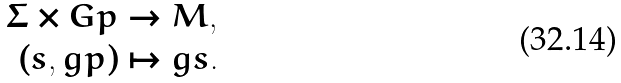<formula> <loc_0><loc_0><loc_500><loc_500>\Sigma \times G p & \to M , \\ ( s , g p ) & \mapsto g s .</formula> 